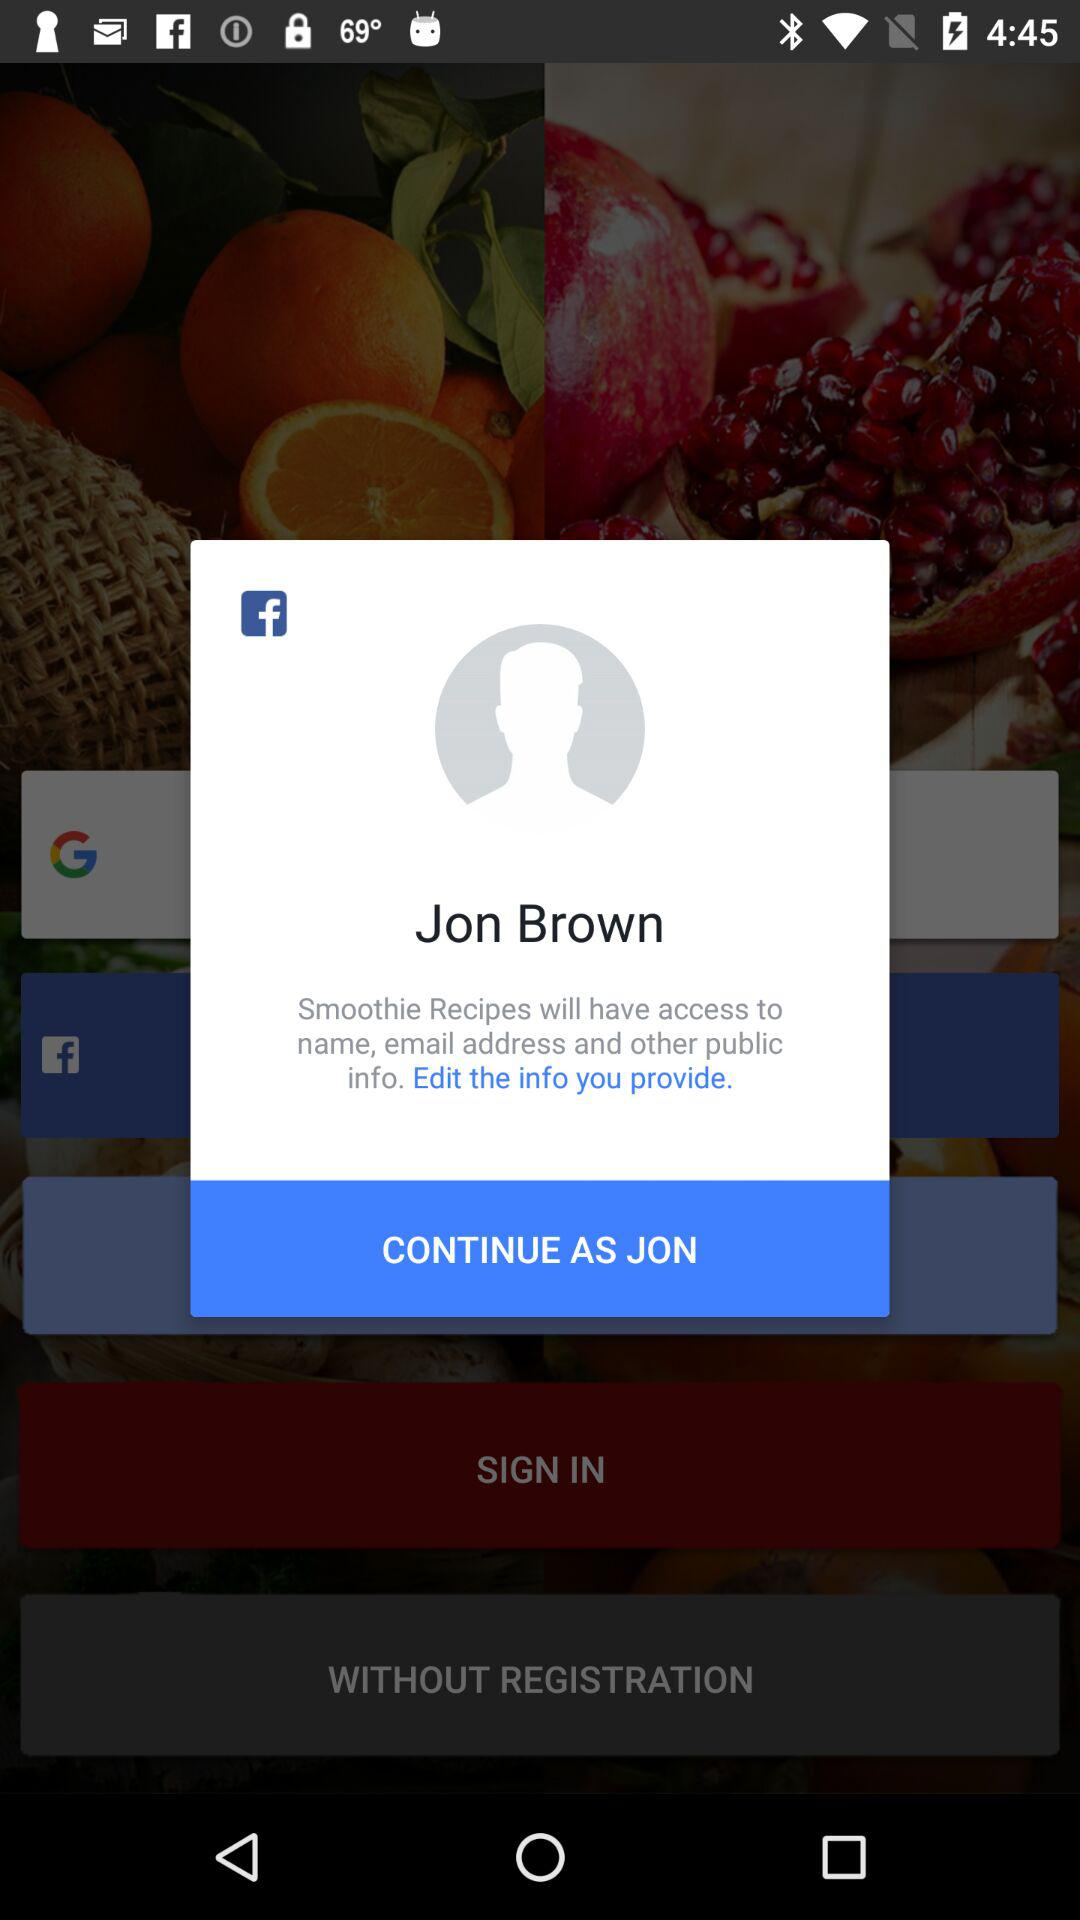Through what applications can we login with? The application is "Facebook". 